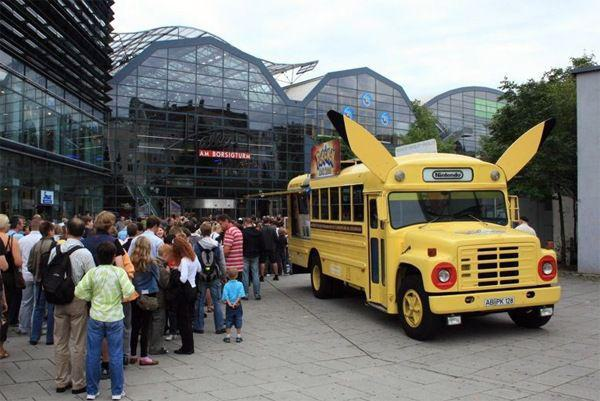Can you describe what's unusual about the vehicle in the image? Certainly! The vehicle in the image is designed to resemble the well-known character Pikachu from the Pokémon franchise. Its bright yellow color and the pointed ears on top make it stand out, and it has been creatively modified to represent Pikachu's face. This playful design is likely intended to attract attention and engage fans of the series.  Is there anything happening in the background of the image? Behind the uniquely designed vehicle, there appears to be a crowd of people. They seem to be queuing up, possibly waiting to partake in an event or to board the vehicle itself. The building in the background has a modern architectural style, with a curved, glass facade that suggests it could be a venue for conventions or other large gatherings. 